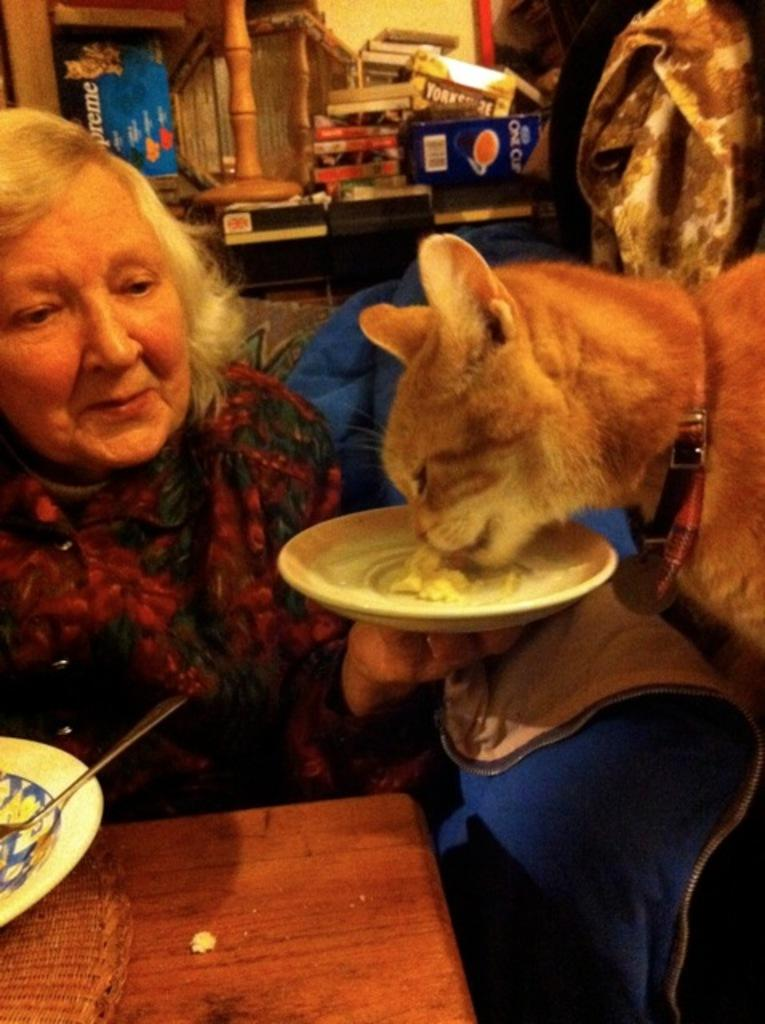Who is in the image? There is a woman in the image. What is the woman doing in the image? The woman is feeding a cat in the image. What objects are present in the image? There is a plate, a spoon, and a table in the image. What type of poison is the woman using to feed the cat in the image? There is no poison present in the image; the woman is feeding the cat using a spoon and a plate. How does the presence of zinc affect the woman and the cat in the image? There is no mention of zinc in the image, so its presence or absence cannot be determined. 